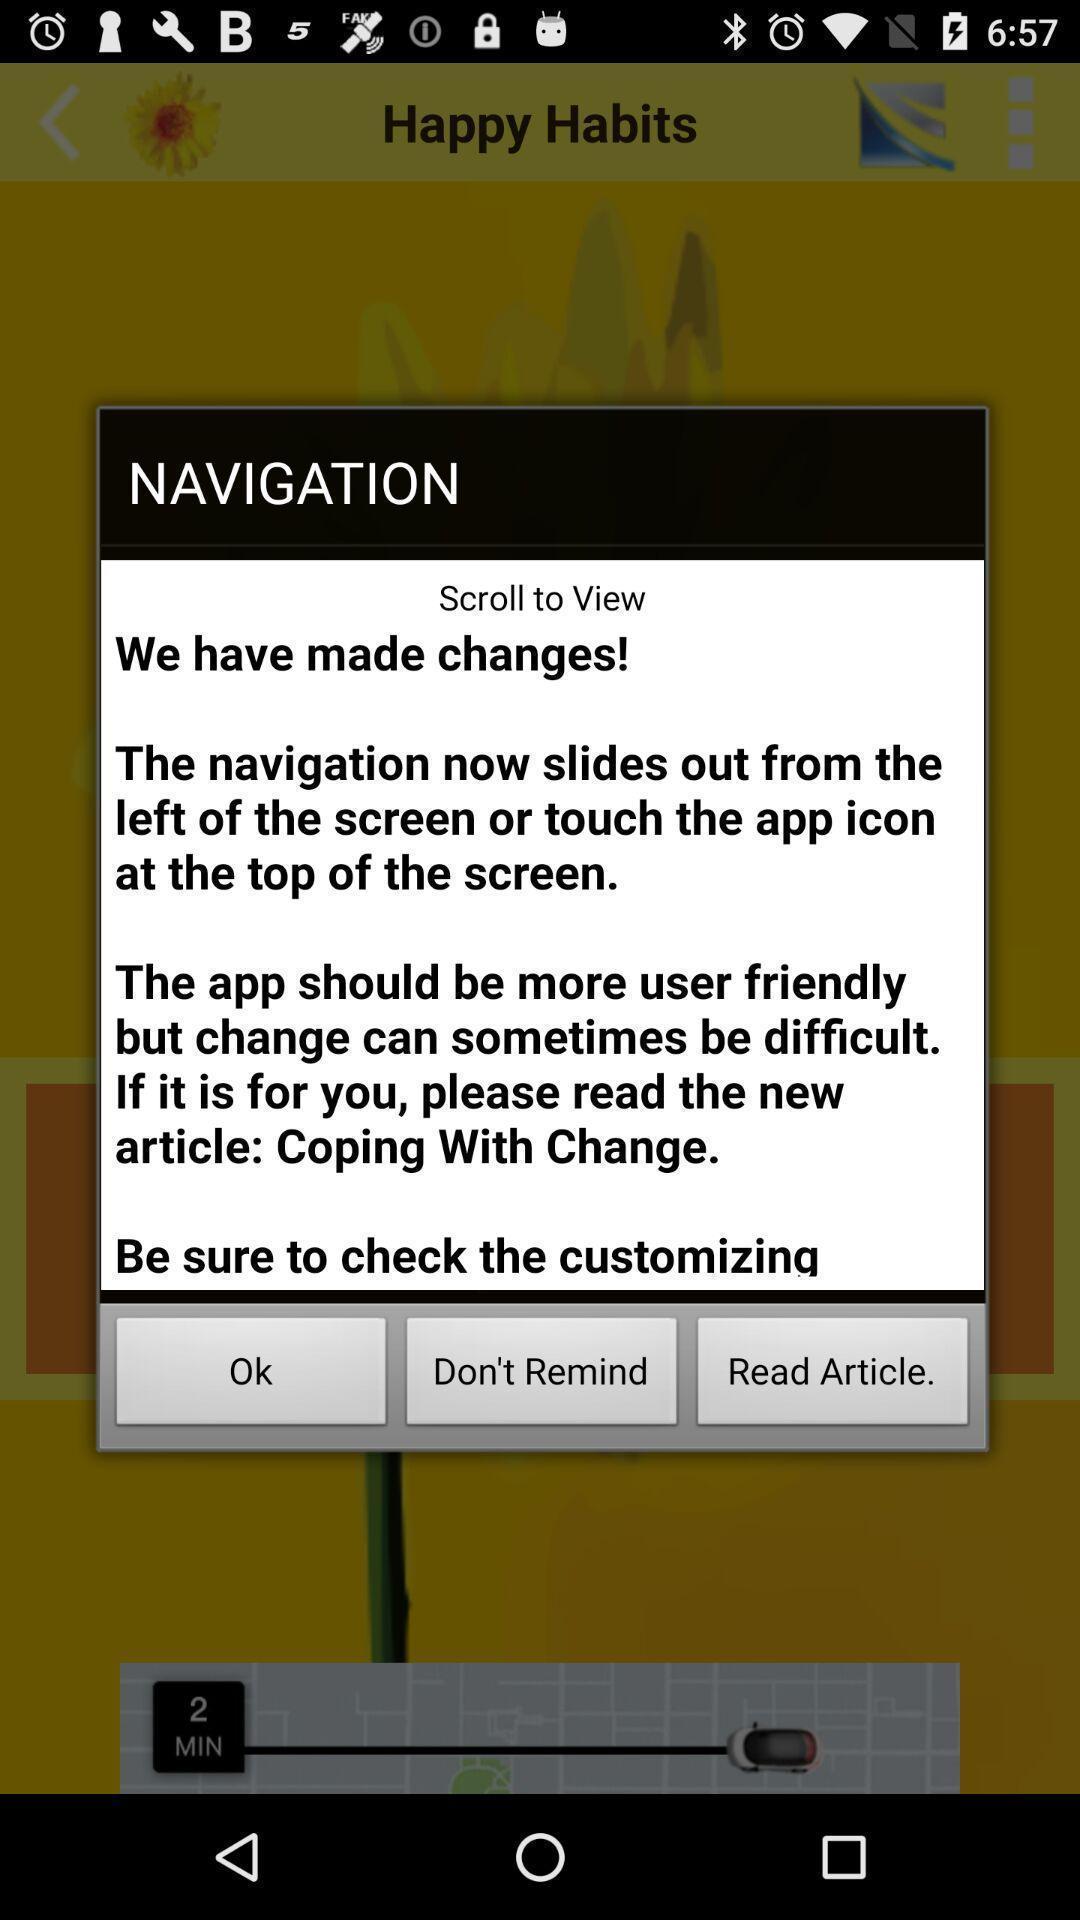Provide a detailed account of this screenshot. Popup showing navigation. 